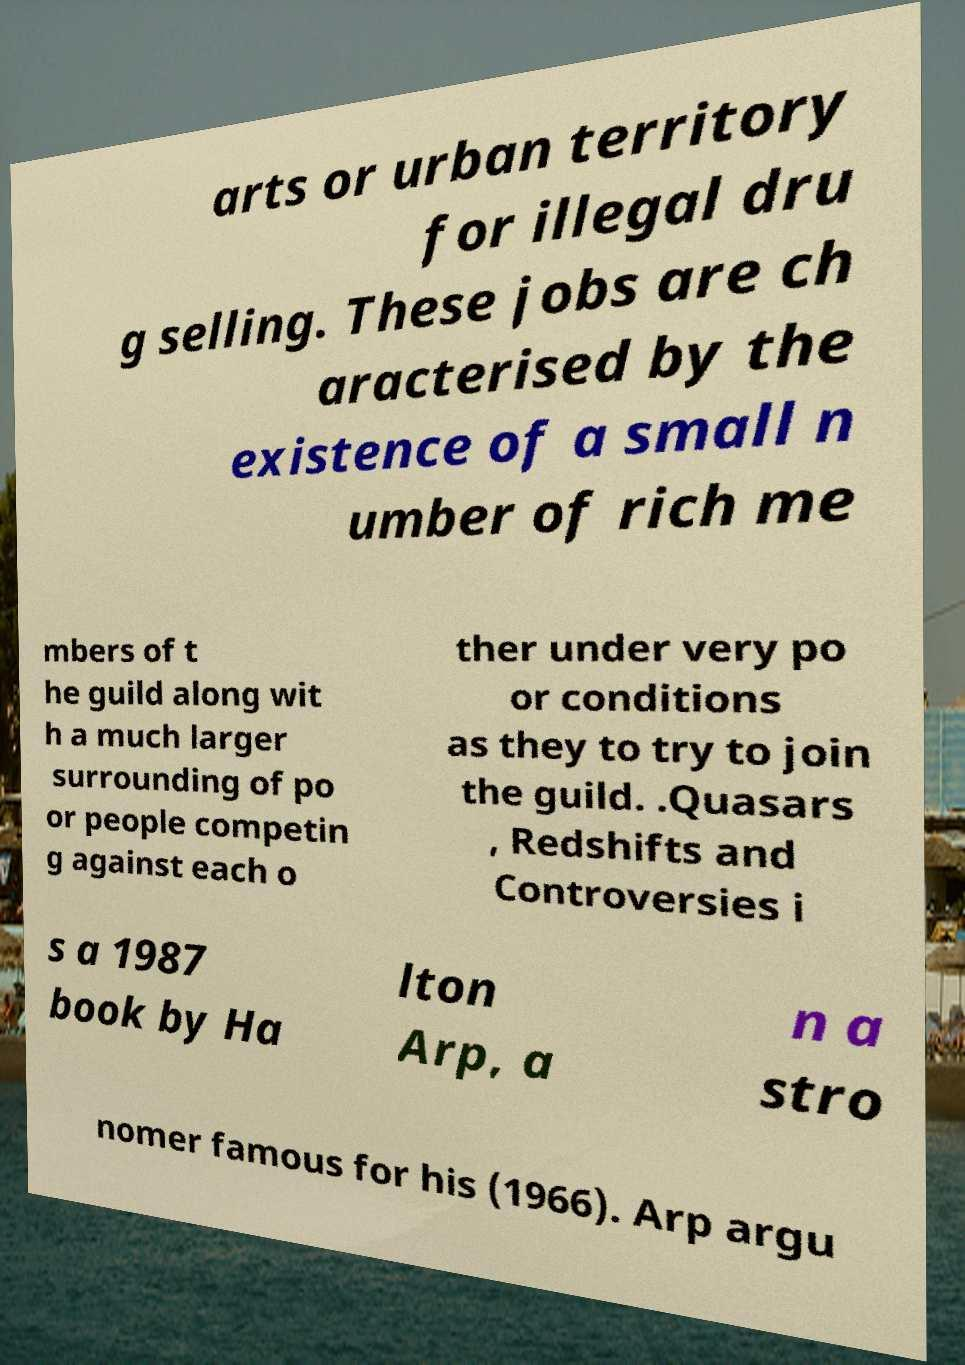Please read and relay the text visible in this image. What does it say? arts or urban territory for illegal dru g selling. These jobs are ch aracterised by the existence of a small n umber of rich me mbers of t he guild along wit h a much larger surrounding of po or people competin g against each o ther under very po or conditions as they to try to join the guild. .Quasars , Redshifts and Controversies i s a 1987 book by Ha lton Arp, a n a stro nomer famous for his (1966). Arp argu 